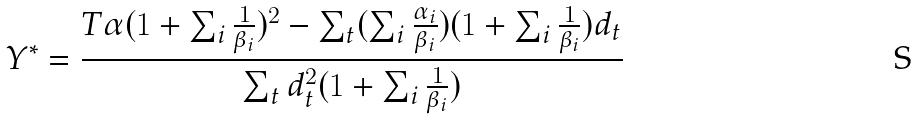Convert formula to latex. <formula><loc_0><loc_0><loc_500><loc_500>Y ^ { * } = \frac { T \alpha ( 1 + \sum _ { i } \frac { 1 } { \beta _ { i } } ) ^ { 2 } - \sum _ { t } ( \sum _ { i } \frac { \alpha _ { i } } { \beta _ { i } } ) ( 1 + \sum _ { i } \frac { 1 } { \beta _ { i } } ) d _ { t } } { \sum _ { t } d _ { t } ^ { 2 } ( 1 + \sum _ { i } \frac { 1 } { \beta _ { i } } ) }</formula> 